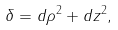Convert formula to latex. <formula><loc_0><loc_0><loc_500><loc_500>\delta = d \rho ^ { 2 } + d z ^ { 2 } ,</formula> 